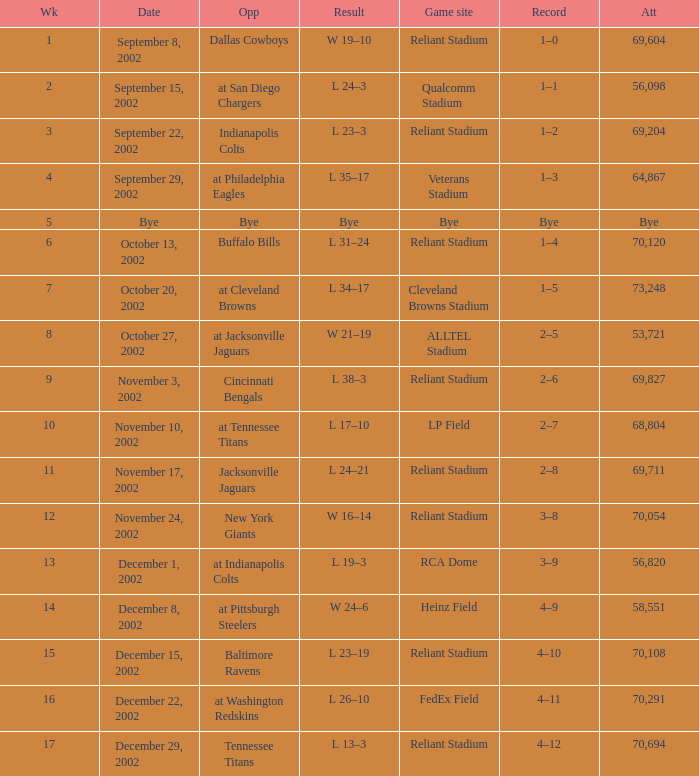When did the Texans play at LP Field? November 10, 2002. 